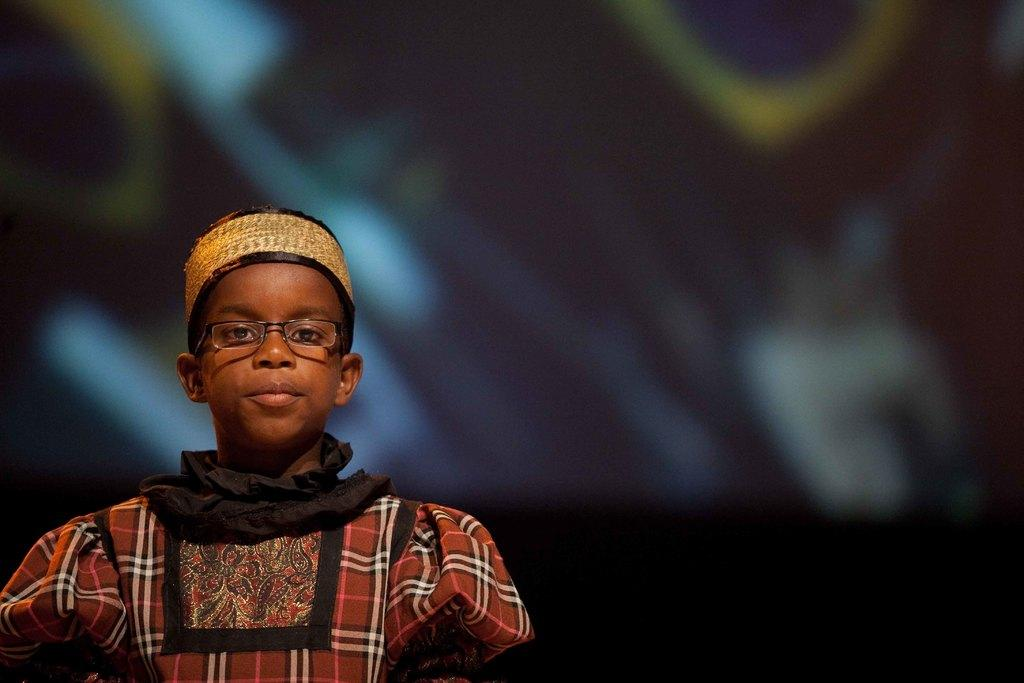What is the main subject of the image? There is a boy in the image. What is the boy doing in the image? The boy is standing. Can you tell me how many scarecrows are in the image? There are no scarecrows present in the image; it features a boy standing. What type of yak can be seen interacting with the boy in the image? There is no yak present in the image; only the boy is visible. 